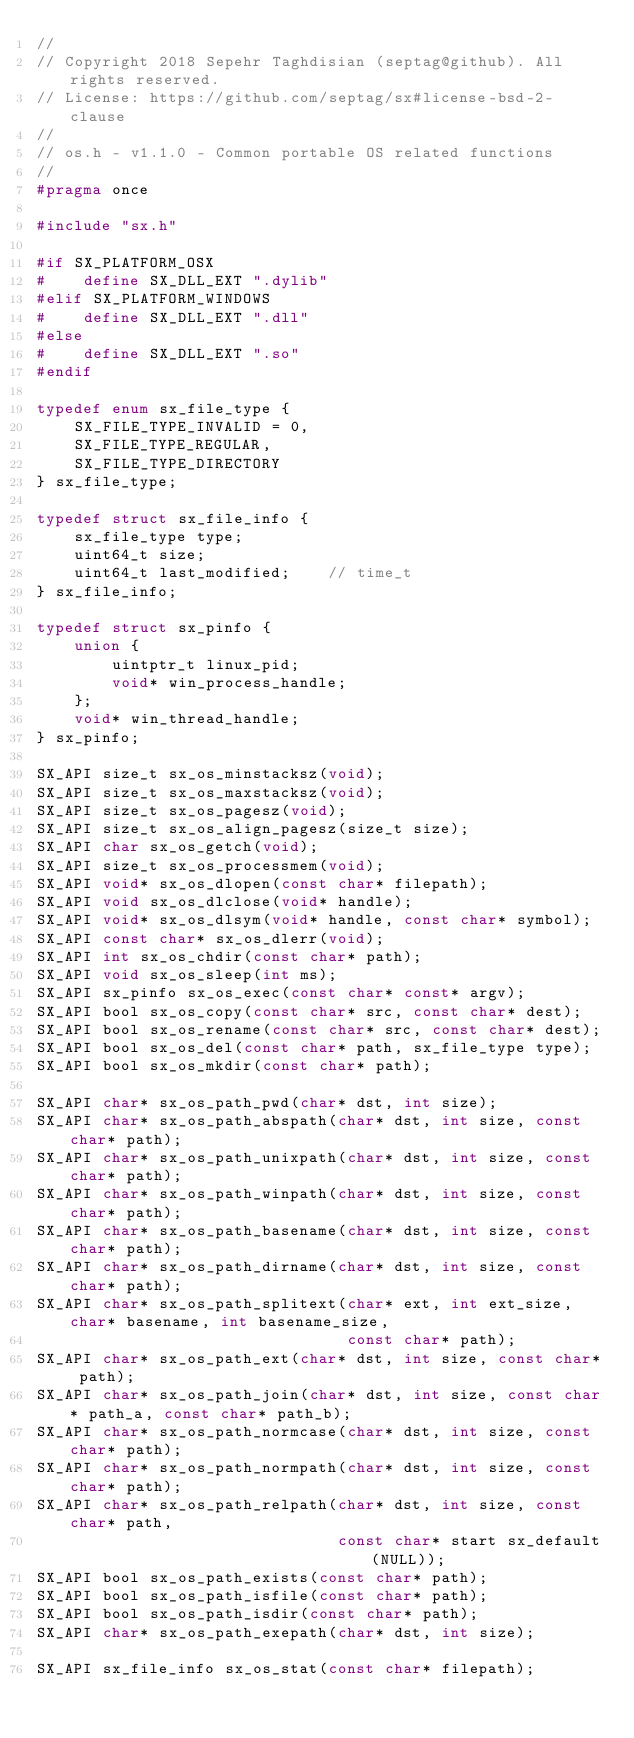<code> <loc_0><loc_0><loc_500><loc_500><_C_>//
// Copyright 2018 Sepehr Taghdisian (septag@github). All rights reserved.
// License: https://github.com/septag/sx#license-bsd-2-clause
//
// os.h - v1.1.0 - Common portable OS related functions
//
#pragma once

#include "sx.h"

#if SX_PLATFORM_OSX
#    define SX_DLL_EXT ".dylib"
#elif SX_PLATFORM_WINDOWS
#    define SX_DLL_EXT ".dll"
#else
#    define SX_DLL_EXT ".so"
#endif

typedef enum sx_file_type {
    SX_FILE_TYPE_INVALID = 0,
    SX_FILE_TYPE_REGULAR,
    SX_FILE_TYPE_DIRECTORY
} sx_file_type;

typedef struct sx_file_info {
    sx_file_type type;
    uint64_t size;
    uint64_t last_modified;    // time_t
} sx_file_info;

typedef struct sx_pinfo {
    union {
        uintptr_t linux_pid;
        void* win_process_handle;
    };
    void* win_thread_handle;
} sx_pinfo;

SX_API size_t sx_os_minstacksz(void);
SX_API size_t sx_os_maxstacksz(void);
SX_API size_t sx_os_pagesz(void);
SX_API size_t sx_os_align_pagesz(size_t size);
SX_API char sx_os_getch(void);
SX_API size_t sx_os_processmem(void);
SX_API void* sx_os_dlopen(const char* filepath);
SX_API void sx_os_dlclose(void* handle);
SX_API void* sx_os_dlsym(void* handle, const char* symbol);
SX_API const char* sx_os_dlerr(void);
SX_API int sx_os_chdir(const char* path);
SX_API void sx_os_sleep(int ms);
SX_API sx_pinfo sx_os_exec(const char* const* argv);
SX_API bool sx_os_copy(const char* src, const char* dest);
SX_API bool sx_os_rename(const char* src, const char* dest);
SX_API bool sx_os_del(const char* path, sx_file_type type);
SX_API bool sx_os_mkdir(const char* path);

SX_API char* sx_os_path_pwd(char* dst, int size);
SX_API char* sx_os_path_abspath(char* dst, int size, const char* path);
SX_API char* sx_os_path_unixpath(char* dst, int size, const char* path);
SX_API char* sx_os_path_winpath(char* dst, int size, const char* path);
SX_API char* sx_os_path_basename(char* dst, int size, const char* path);
SX_API char* sx_os_path_dirname(char* dst, int size, const char* path);
SX_API char* sx_os_path_splitext(char* ext, int ext_size, char* basename, int basename_size,
                                 const char* path);
SX_API char* sx_os_path_ext(char* dst, int size, const char* path);
SX_API char* sx_os_path_join(char* dst, int size, const char* path_a, const char* path_b);
SX_API char* sx_os_path_normcase(char* dst, int size, const char* path);
SX_API char* sx_os_path_normpath(char* dst, int size, const char* path);
SX_API char* sx_os_path_relpath(char* dst, int size, const char* path,
                                const char* start sx_default(NULL));
SX_API bool sx_os_path_exists(const char* path);
SX_API bool sx_os_path_isfile(const char* path);
SX_API bool sx_os_path_isdir(const char* path);
SX_API char* sx_os_path_exepath(char* dst, int size);

SX_API sx_file_info sx_os_stat(const char* filepath);
</code> 